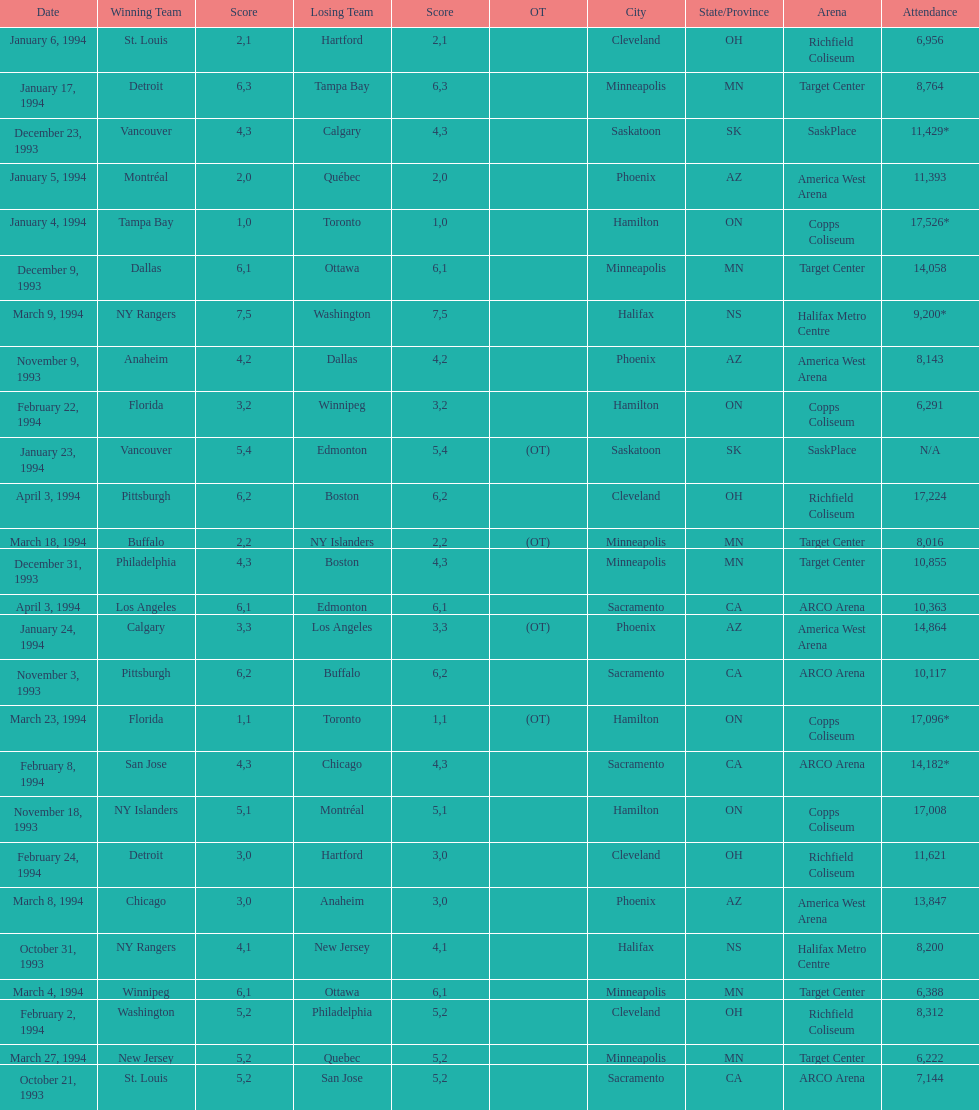The game on which date had the most attendance? January 4, 1994. 